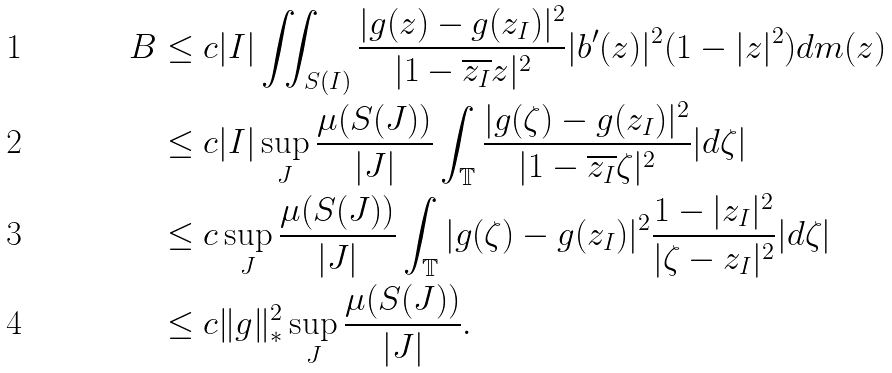Convert formula to latex. <formula><loc_0><loc_0><loc_500><loc_500>B & \leq c | I | \iint _ { S ( I ) } \frac { | g ( z ) - g ( z _ { I } ) | ^ { 2 } } { | 1 - \overline { z _ { I } } z | ^ { 2 } } | b ^ { \prime } ( z ) | ^ { 2 } ( 1 - | z | ^ { 2 } ) d m ( z ) \\ & \leq c | I | \sup _ { J } \frac { \mu ( S ( J ) ) } { | J | } \int _ { \mathbb { T } } \frac { | g ( \zeta ) - g ( z _ { I } ) | ^ { 2 } } { | 1 - \overline { z _ { I } } \zeta | ^ { 2 } } | d \zeta | \\ & \leq c \sup _ { J } \frac { \mu ( S ( J ) ) } { | J | } \int _ { \mathbb { T } } | g ( \zeta ) - g ( z _ { I } ) | ^ { 2 } \frac { 1 - | z _ { I } | ^ { 2 } } { | \zeta - z _ { I } | ^ { 2 } } | d \zeta | \\ & \leq c \| g \| _ { * } ^ { 2 } \sup _ { J } \frac { \mu ( S ( J ) ) } { | J | } .</formula> 